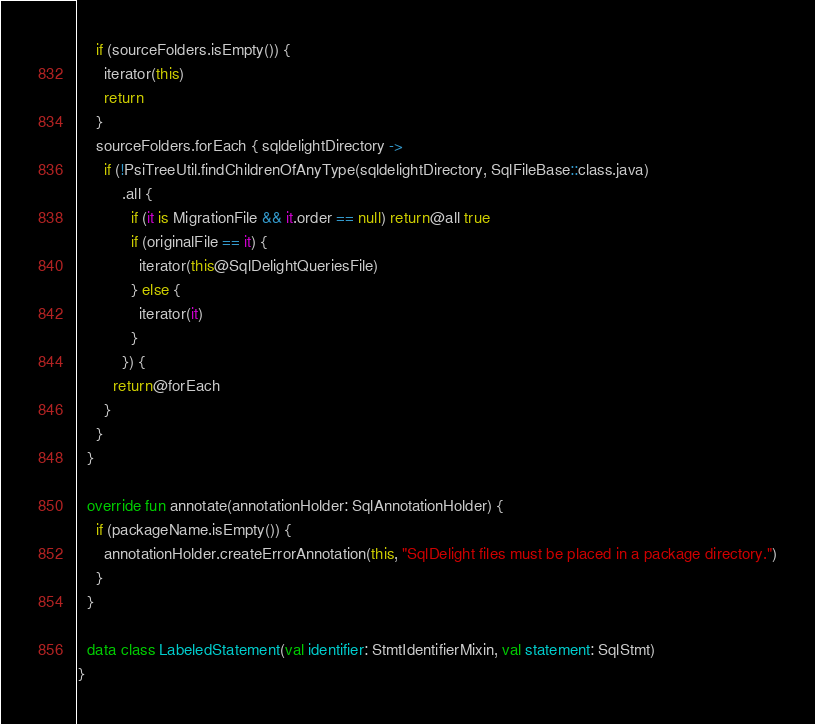Convert code to text. <code><loc_0><loc_0><loc_500><loc_500><_Kotlin_>    if (sourceFolders.isEmpty()) {
      iterator(this)
      return
    }
    sourceFolders.forEach { sqldelightDirectory ->
      if (!PsiTreeUtil.findChildrenOfAnyType(sqldelightDirectory, SqlFileBase::class.java)
          .all {
            if (it is MigrationFile && it.order == null) return@all true
            if (originalFile == it) {
              iterator(this@SqlDelightQueriesFile)
            } else {
              iterator(it)
            }
          }) {
        return@forEach
      }
    }
  }

  override fun annotate(annotationHolder: SqlAnnotationHolder) {
    if (packageName.isEmpty()) {
      annotationHolder.createErrorAnnotation(this, "SqlDelight files must be placed in a package directory.")
    }
  }

  data class LabeledStatement(val identifier: StmtIdentifierMixin, val statement: SqlStmt)
}
</code> 